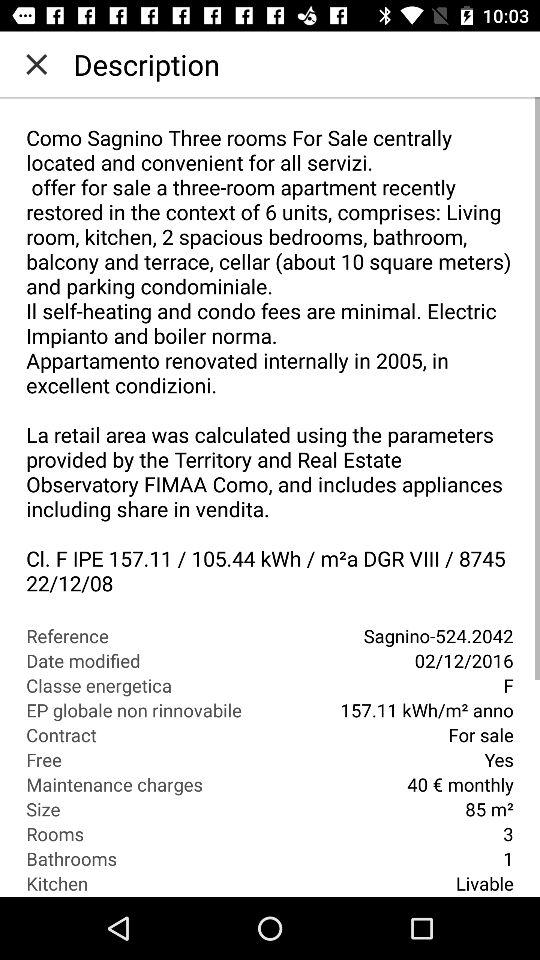What are the maintenance charges for a month? The maintenance charges for a month are €40. 